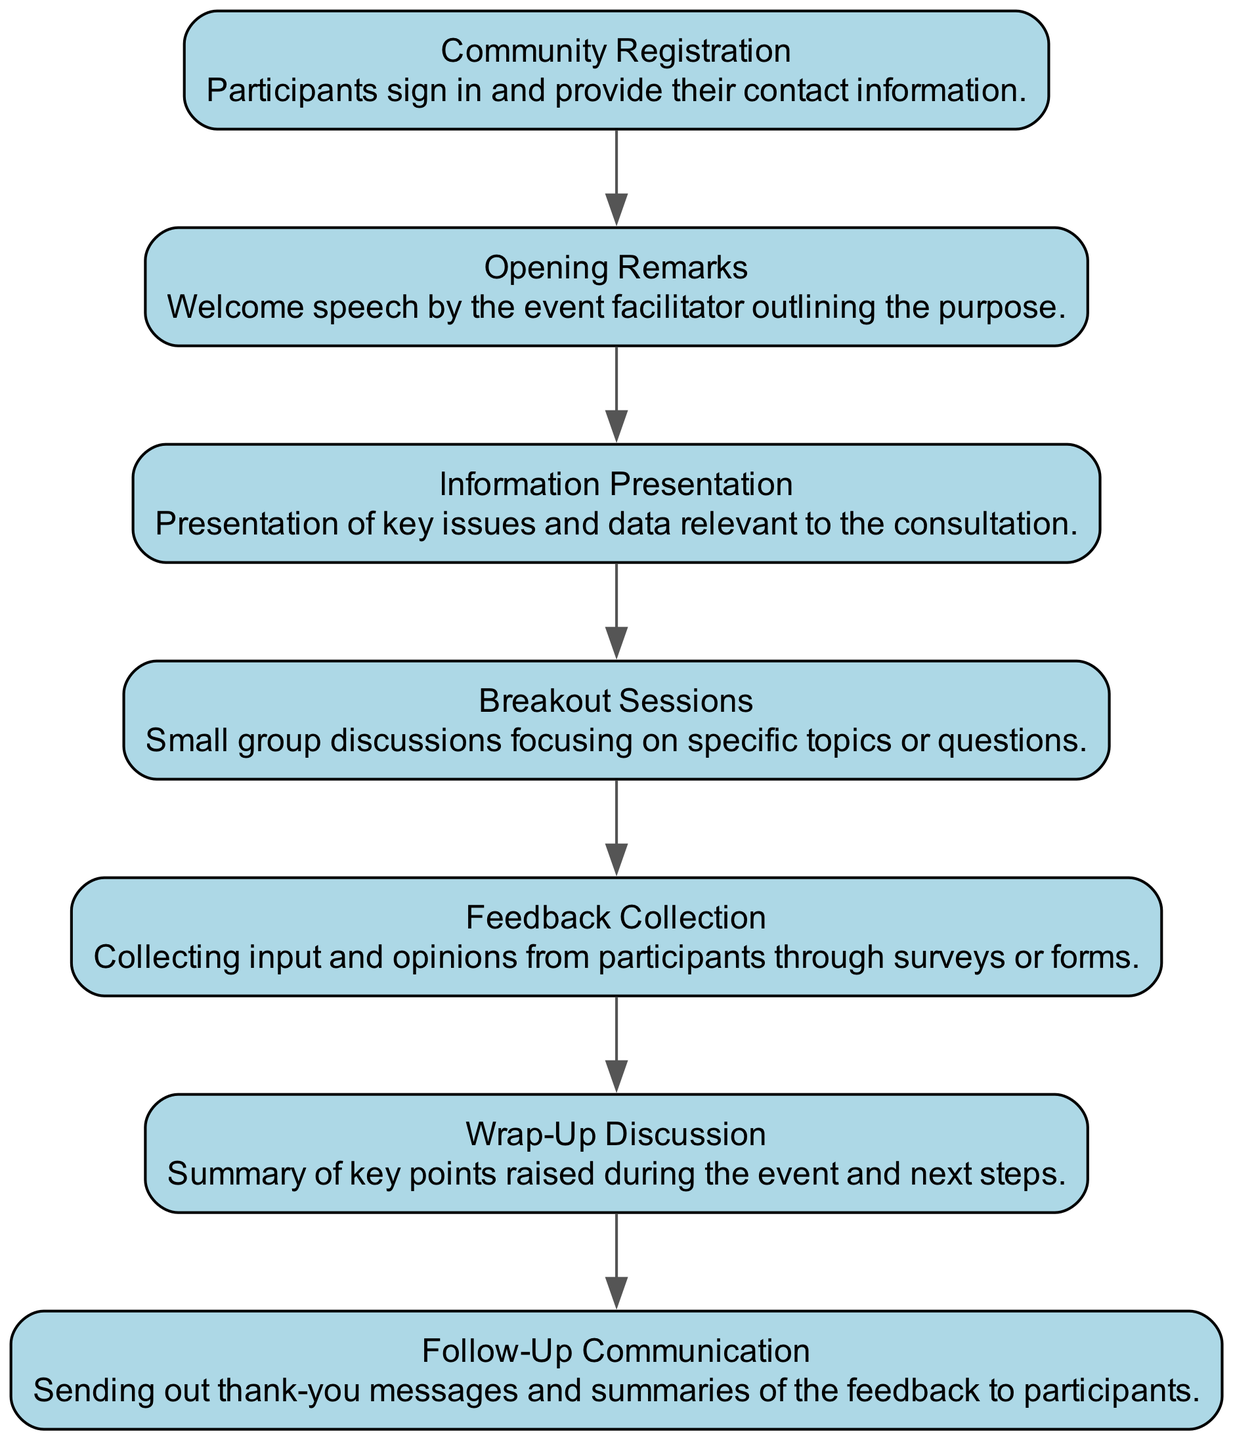What is the first activity in the sequence? The first activity listed in the diagram is "Community Registration," as it is the initial step that participants undertake.
Answer: Community Registration How many total activities are represented in the diagram? By counting each of the activities listed, there are a total of 7 distinct activities represented in the diagram.
Answer: 7 What follows after the "Information Presentation"? The activity that directly follows "Information Presentation" in the sequence is "Breakout Sessions" which is connected as the next step in the process.
Answer: Breakout Sessions What is the purpose of the "Wrap-Up Discussion"? The purpose of the "Wrap-Up Discussion" is to summarize the key points raised during the event and outline the next steps, as stated in its description.
Answer: Summary of key points and next steps Which activity involves collecting participant input? The specific activity that involves gathering feedback from participants is "Feedback Collection", which is dedicated to this purpose during the event.
Answer: Feedback Collection How does "Follow-Up Communication" relate to the previous activities? "Follow-Up Communication" is the final step that communicates with participants after the event to send thank-you messages and feedback summaries, indicating it is a culmination of previous activities' outcomes.
Answer: Final step after all activities Which two activities are focused on discussion? The two activities concentrated on discussion are "Breakout Sessions" and "Wrap-Up Discussion," both designed to facilitate dialogue among participants.
Answer: Breakout Sessions and Wrap-Up Discussion 